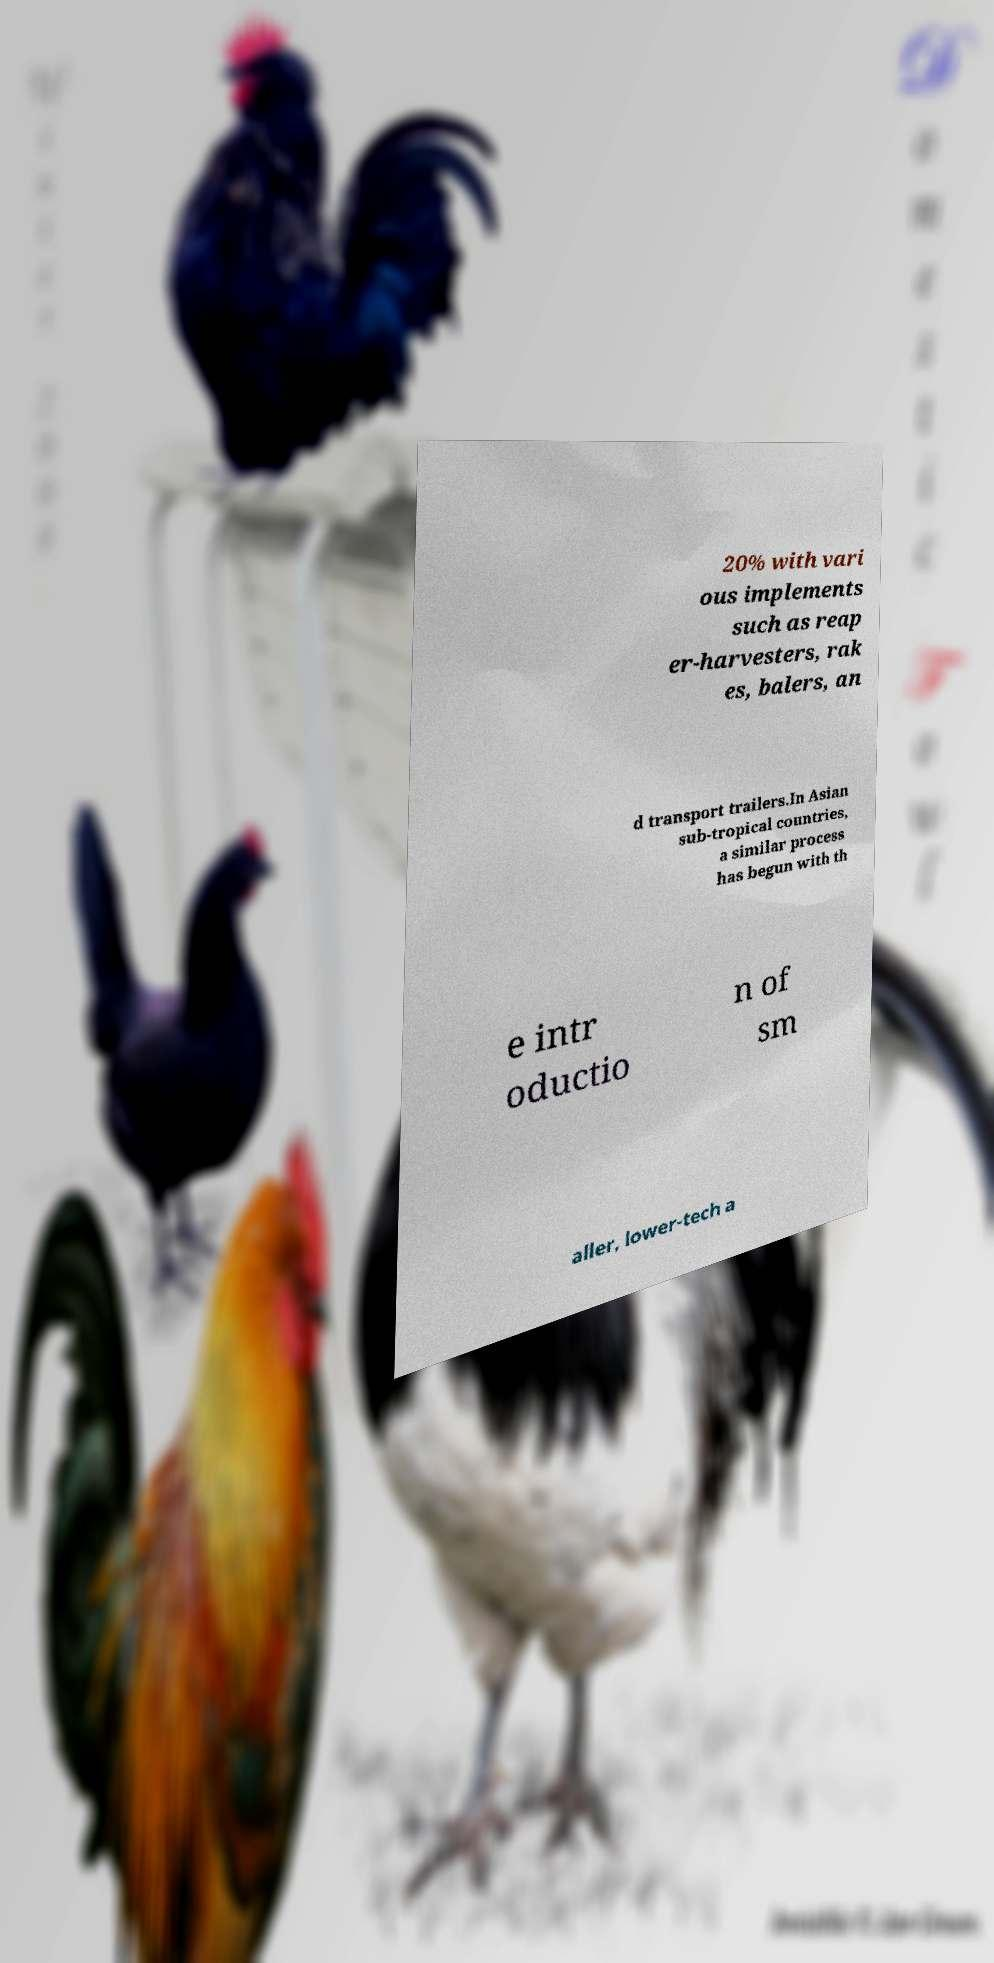I need the written content from this picture converted into text. Can you do that? 20% with vari ous implements such as reap er-harvesters, rak es, balers, an d transport trailers.In Asian sub-tropical countries, a similar process has begun with th e intr oductio n of sm aller, lower-tech a 